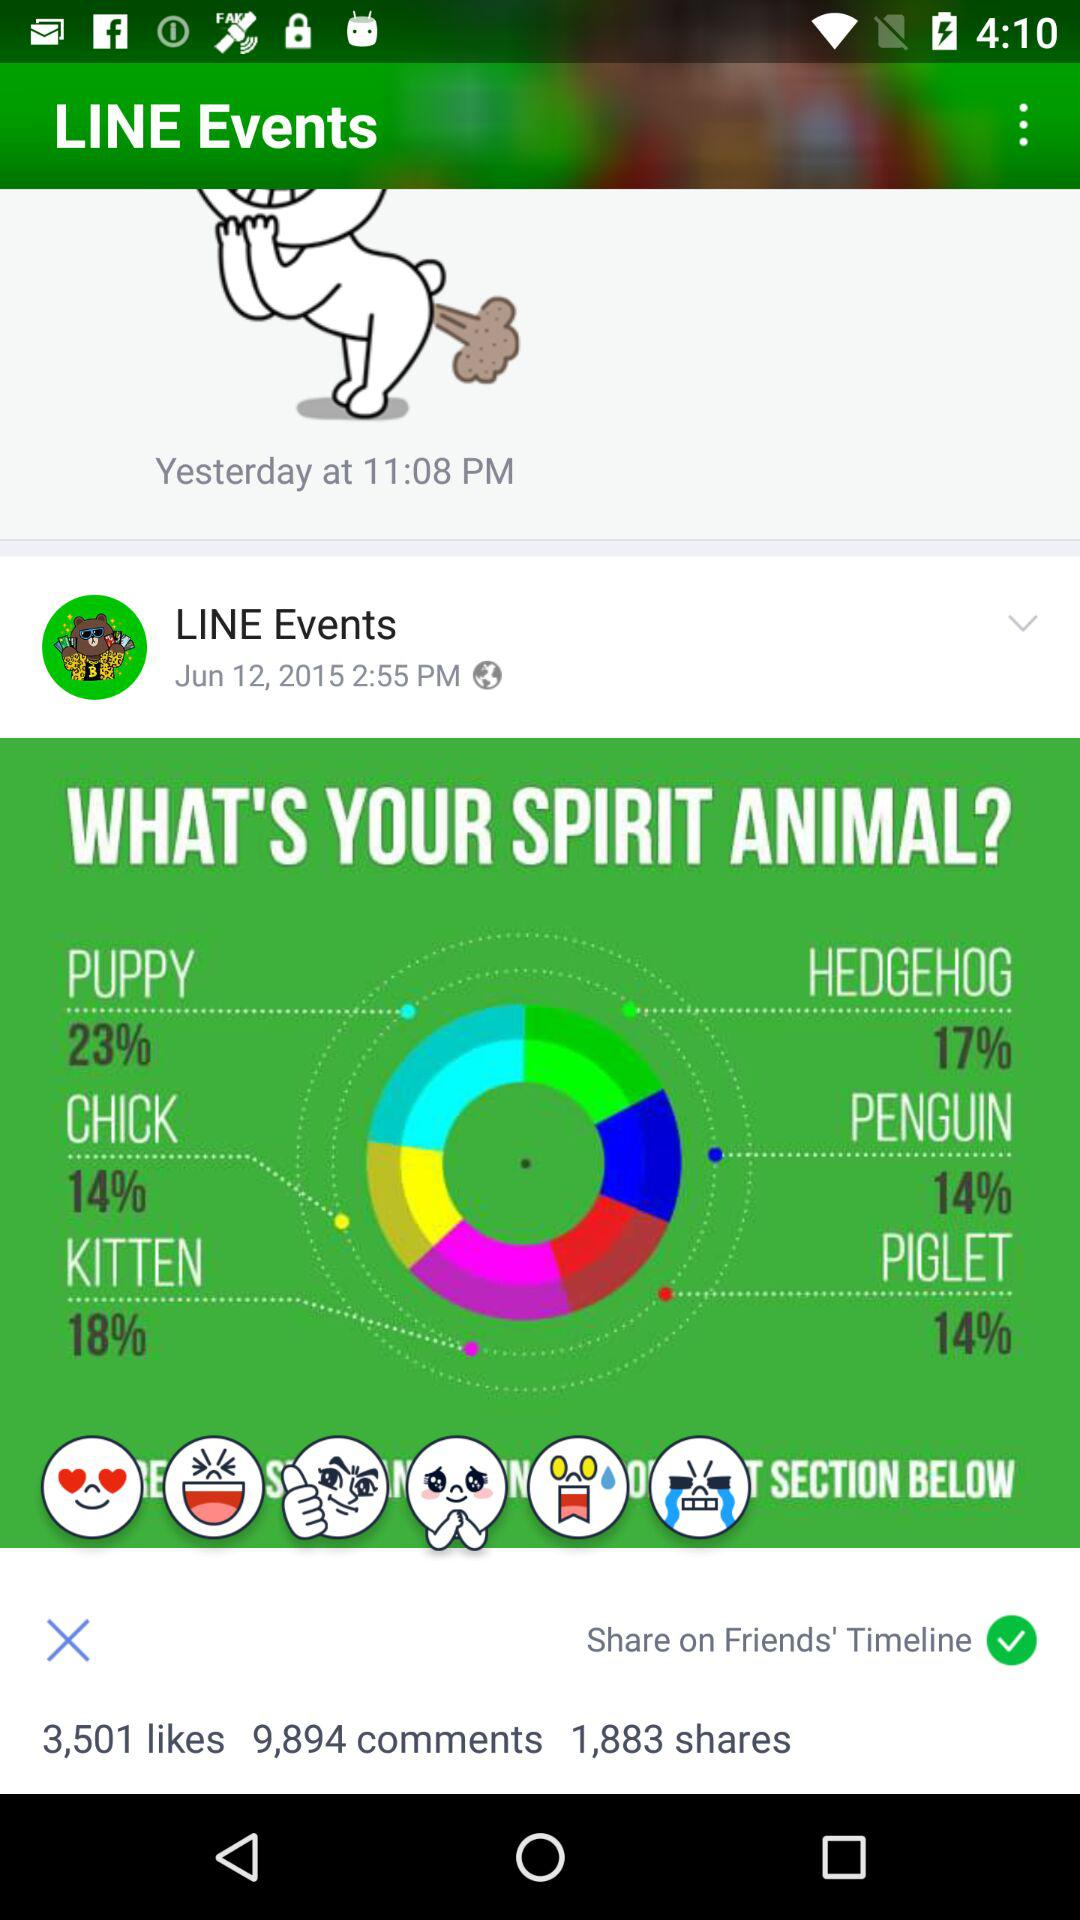What is the percentage of kitten? The percentage of kitten is 18. 